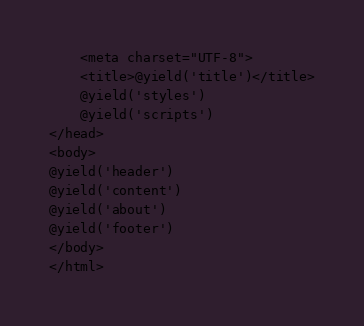Convert code to text. <code><loc_0><loc_0><loc_500><loc_500><_PHP_>    <meta charset="UTF-8">
    <title>@yield('title')</title>
    @yield('styles')
    @yield('scripts')
</head>
<body>
@yield('header')
@yield('content')
@yield('about')
@yield('footer')
</body>
</html></code> 